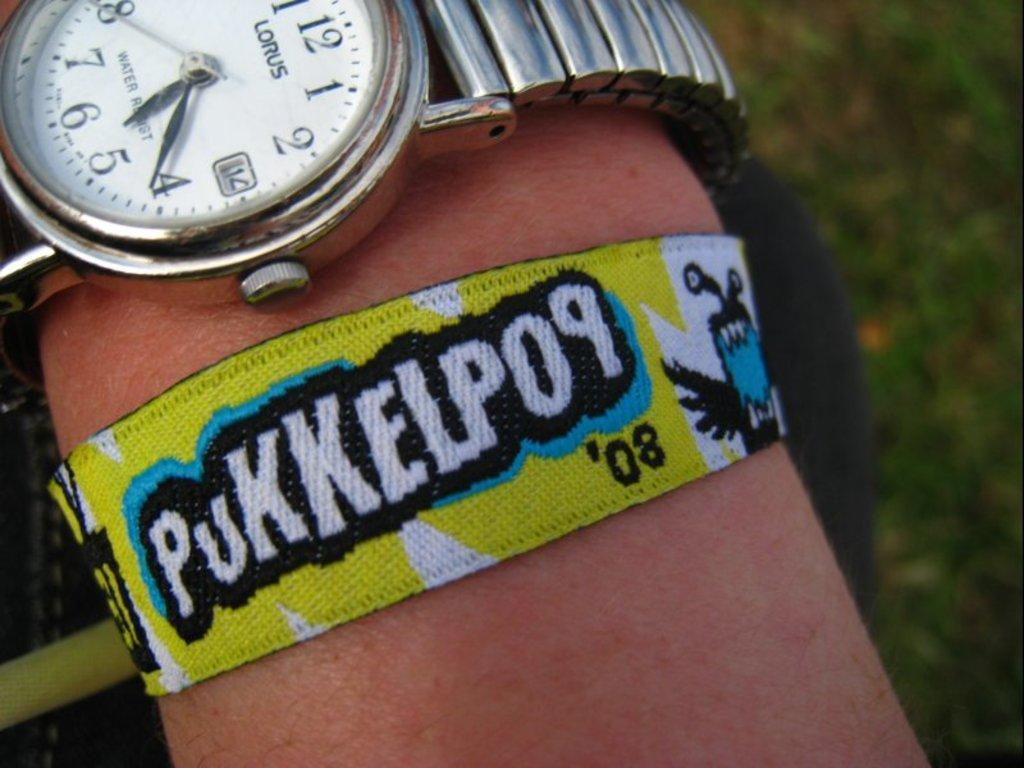<image>
Summarize the visual content of the image. A person displaying a wristband they are wearing at 5:21. 